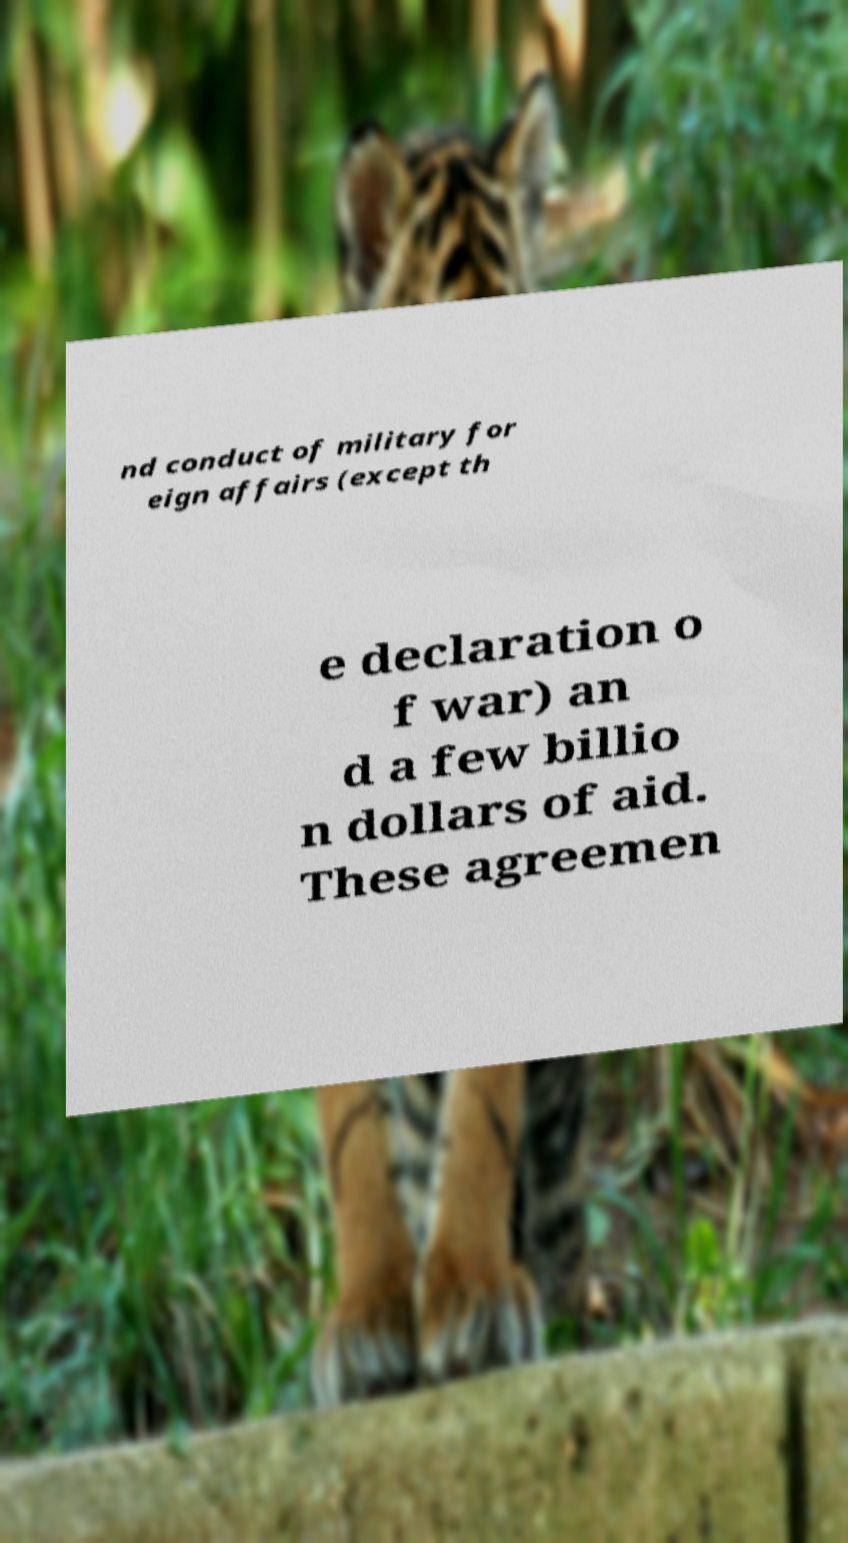There's text embedded in this image that I need extracted. Can you transcribe it verbatim? nd conduct of military for eign affairs (except th e declaration o f war) an d a few billio n dollars of aid. These agreemen 